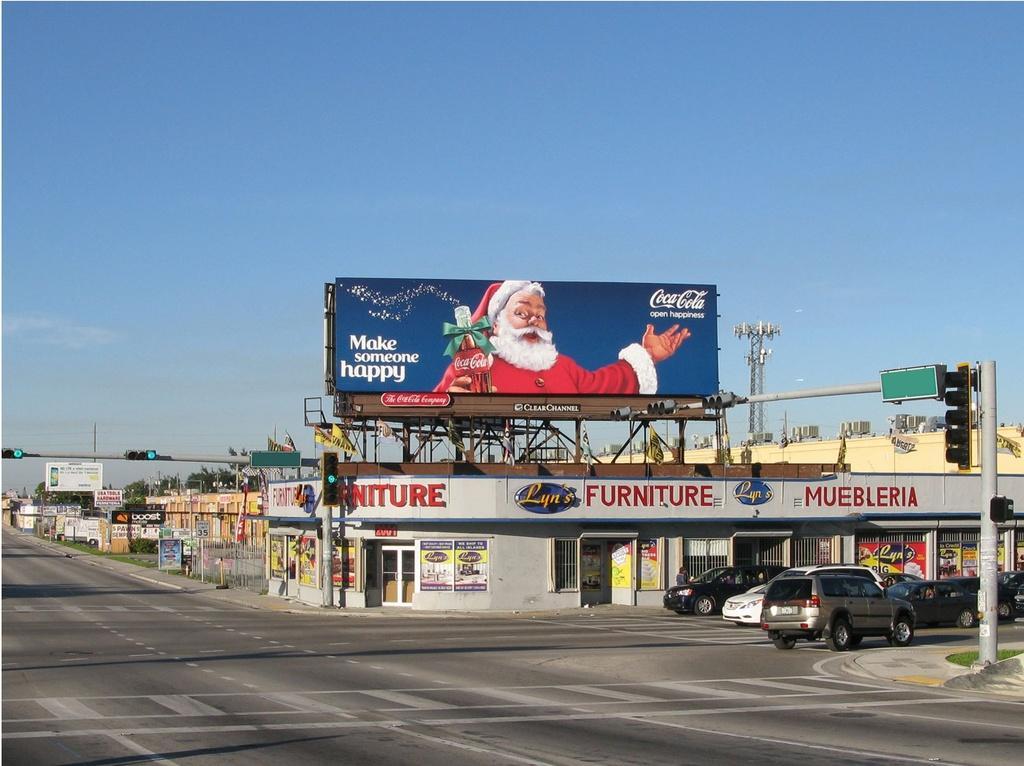Can you describe this image briefly? In this picture I can see vehicles on the road. I can see poles, lights, boards, buildings, trees, and in the background there is the sky. 